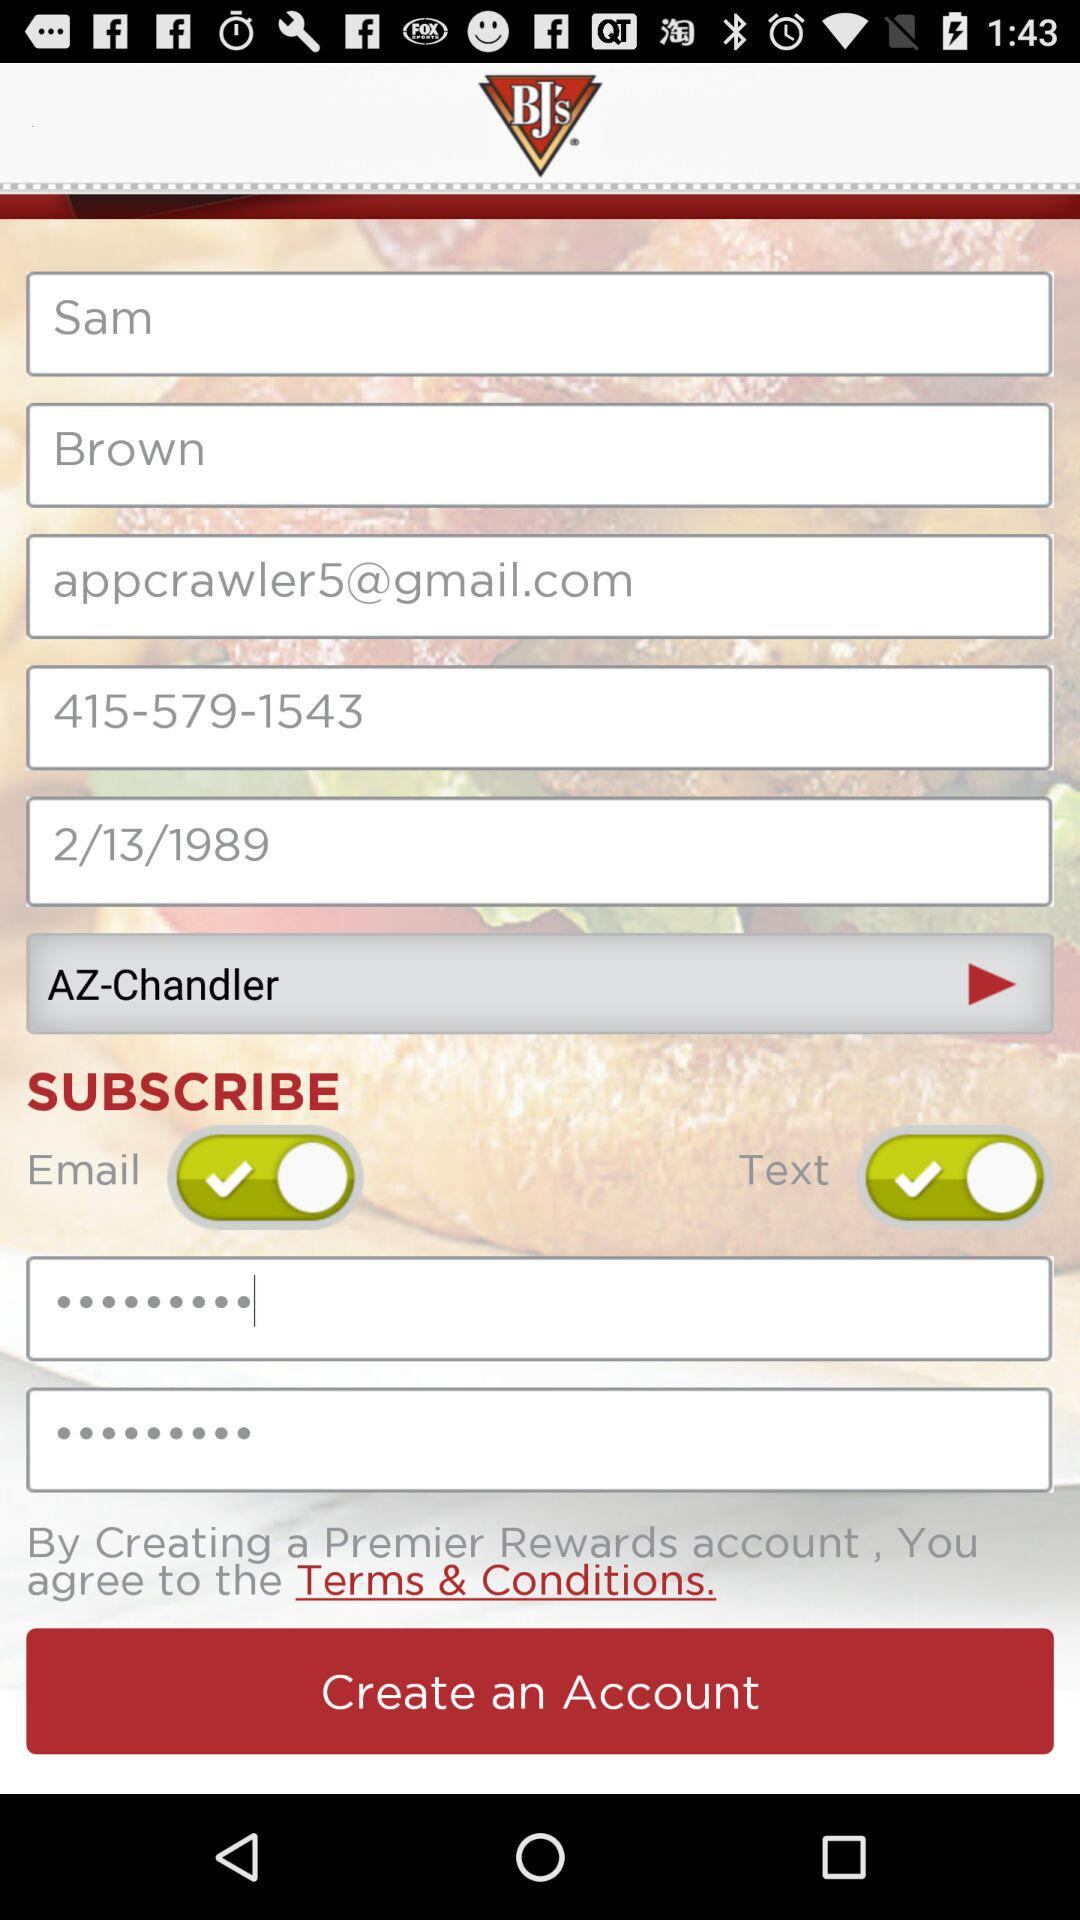What is the status of "Text"? The status of "Text" is "on". 